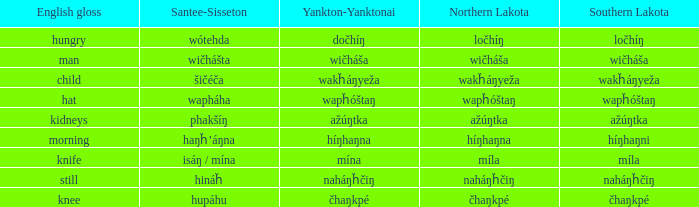Name the santee sisseton for wičháša Wičhášta. 